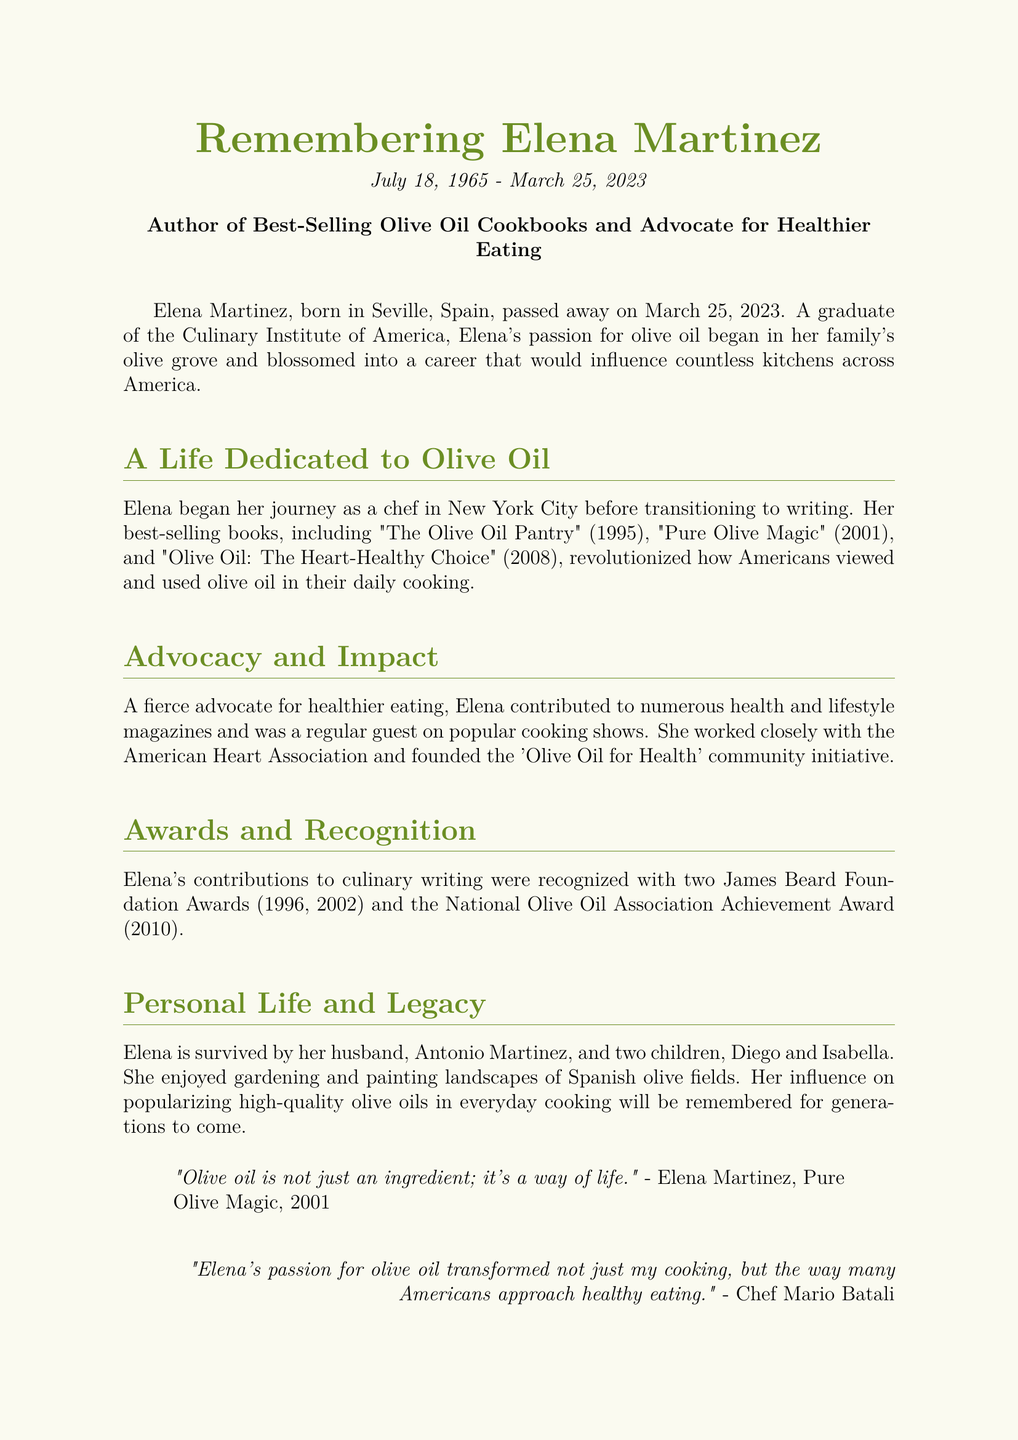What is the full name of the person remembered in the obituary? The document specifies the name of the person remembered as Elena Martinez.
Answer: Elena Martinez What date did Elena Martinez pass away? The obituary states that she passed away on March 25, 2023.
Answer: March 25, 2023 What is the title of one of Elena's best-selling cookbooks? The document lists several titles, including "The Olive Oil Pantry" as one example.
Answer: The Olive Oil Pantry Which institution did Elena graduate from? The obituary mentions that she graduated from the Culinary Institute of America.
Answer: Culinary Institute of America How many James Beard Foundation Awards did Elena receive? The document cites that Elena received two James Beard Foundation Awards.
Answer: Two What community initiative did Elena found? The obituary refers to her founding the 'Olive Oil for Health' community initiative.
Answer: Olive Oil for Health What year was "Pure Olive Magic" published? The document specifies that "Pure Olive Magic" was published in 2001.
Answer: 2001 How many children did Elena have? The document states that she is survived by two children.
Answer: Two Who is quoted in the document expressing Elena's impact on cooking? The quote from Chef Mario Batali reflects on her influence.
Answer: Chef Mario Batali 